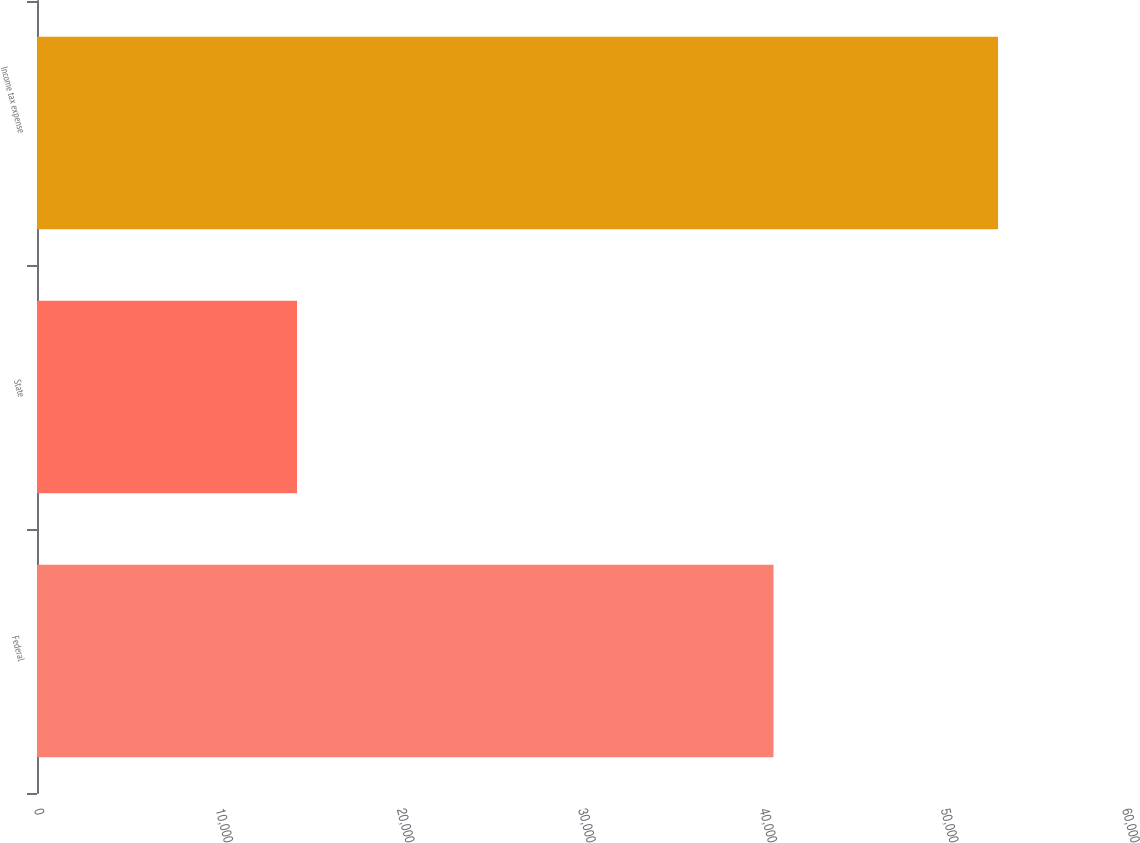<chart> <loc_0><loc_0><loc_500><loc_500><bar_chart><fcel>Federal<fcel>State<fcel>Income tax expense<nl><fcel>40615<fcel>14341<fcel>52998<nl></chart> 